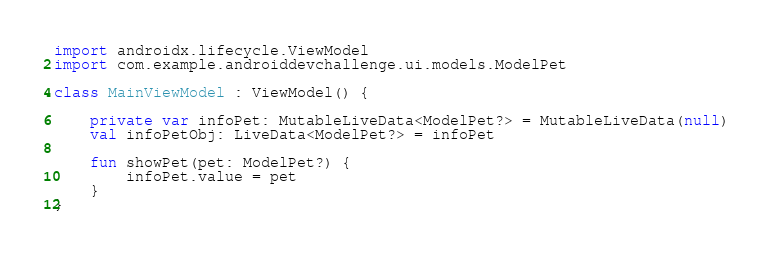<code> <loc_0><loc_0><loc_500><loc_500><_Kotlin_>import androidx.lifecycle.ViewModel
import com.example.androiddevchallenge.ui.models.ModelPet

class MainViewModel : ViewModel() {

    private var infoPet: MutableLiveData<ModelPet?> = MutableLiveData(null)
    val infoPetObj: LiveData<ModelPet?> = infoPet

    fun showPet(pet: ModelPet?) {
        infoPet.value = pet
    }
}
</code> 